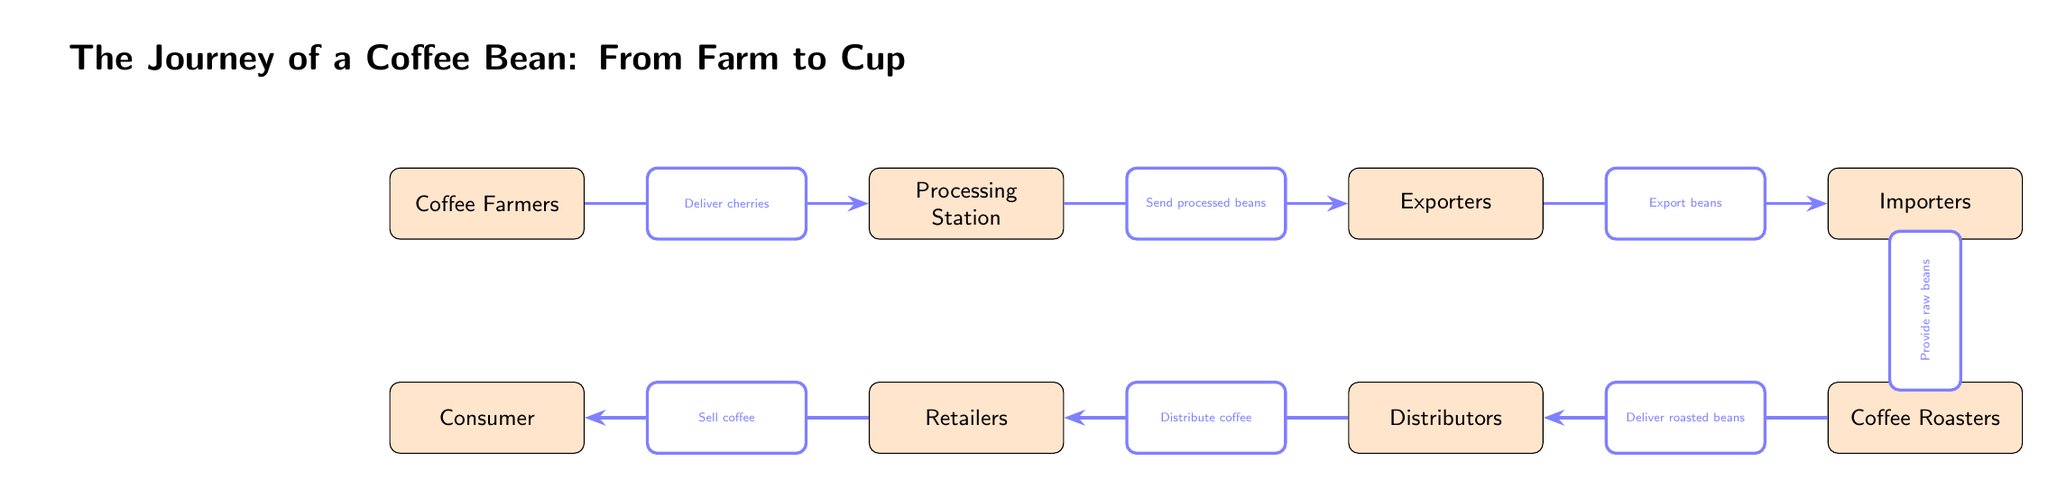What is the first step in the coffee bean journey? According to the diagram, the first step is where coffee farmers are involved in the chain, delivering coffee cherries to the processing station.
Answer: Coffee Farmers How many nodes are there in total? By counting each unique stakeholder and step displayed in the diagram, we find that there are a total of seven nodes: Coffee Farmers, Processing Station, Exporters, Importers, Coffee Roasters, Distributors, and Retailers.
Answer: Seven What do processors send to exporters? The diagram specifies that processing stations send processed beans to the exporters as part of the coffee bean journey.
Answer: Processed Beans Which stakeholder provides raw beans to roasters? The diagram indicates that importers are responsible for providing raw beans to the coffee roasters.
Answer: Importers What is the final step before coffee reaches the consumer? The diagram shows that the step just before the consumer receives the coffee is from retailers who sell coffee.
Answer: Retailers Describe the flow from exporting to importing. Exporters handle the export of beans to importers. This flow signifies how beans transition from exportation at one stage to importation at the next.
Answer: Export beans What do distributors do with roasted beans? The diagram highlights that distributors take delivery of roasted beans from coffee roasters and are responsible for distributing coffee to retailers.
Answer: Distribute coffee What is the role of coffee farmers? According to the diagram, the primary role of coffee farmers is to deliver cherries to the processing station, initiating the coffee bean journey.
Answer: Deliver cherries 